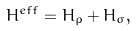Convert formula to latex. <formula><loc_0><loc_0><loc_500><loc_500>H ^ { e f f } = H _ { \rho } + H _ { \sigma } ,</formula> 